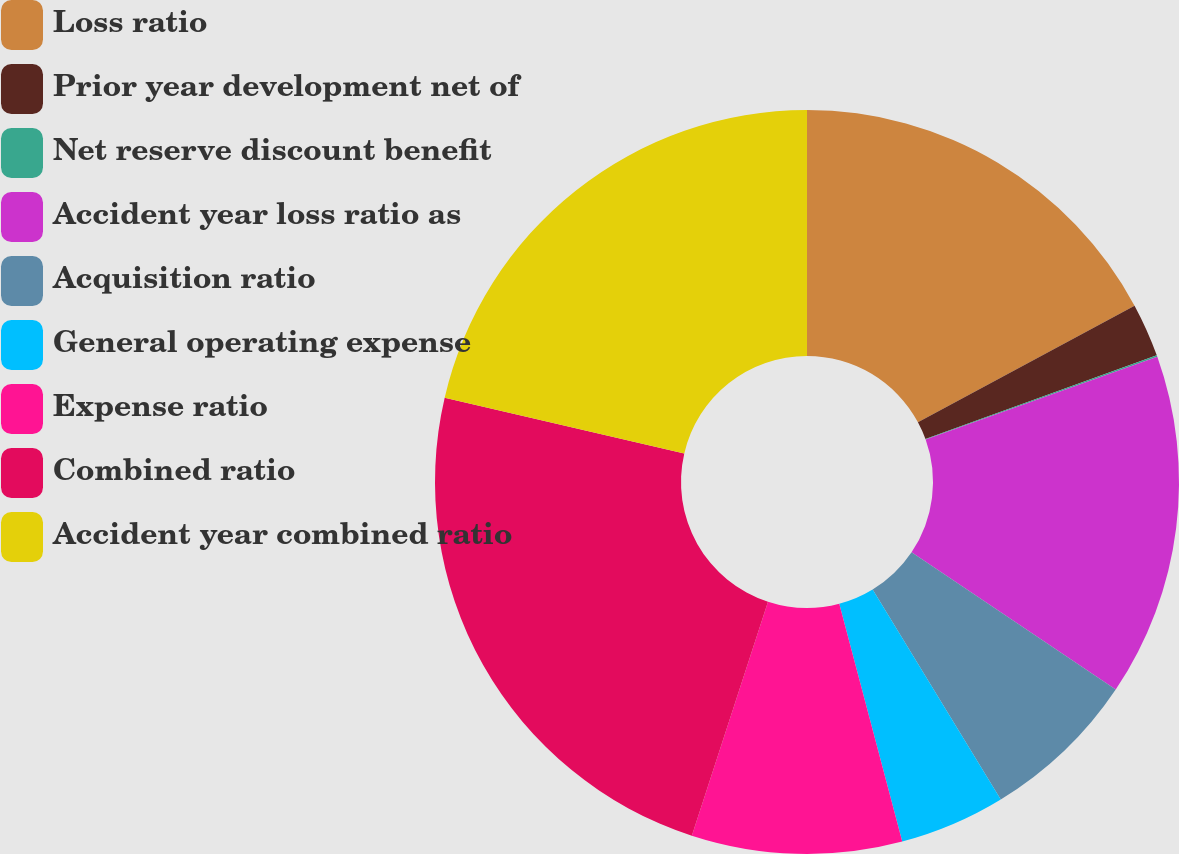Convert chart. <chart><loc_0><loc_0><loc_500><loc_500><pie_chart><fcel>Loss ratio<fcel>Prior year development net of<fcel>Net reserve discount benefit<fcel>Accident year loss ratio as<fcel>Acquisition ratio<fcel>General operating expense<fcel>Expense ratio<fcel>Combined ratio<fcel>Accident year combined ratio<nl><fcel>17.14%<fcel>2.33%<fcel>0.07%<fcel>14.88%<fcel>6.86%<fcel>4.6%<fcel>9.13%<fcel>23.63%<fcel>21.36%<nl></chart> 